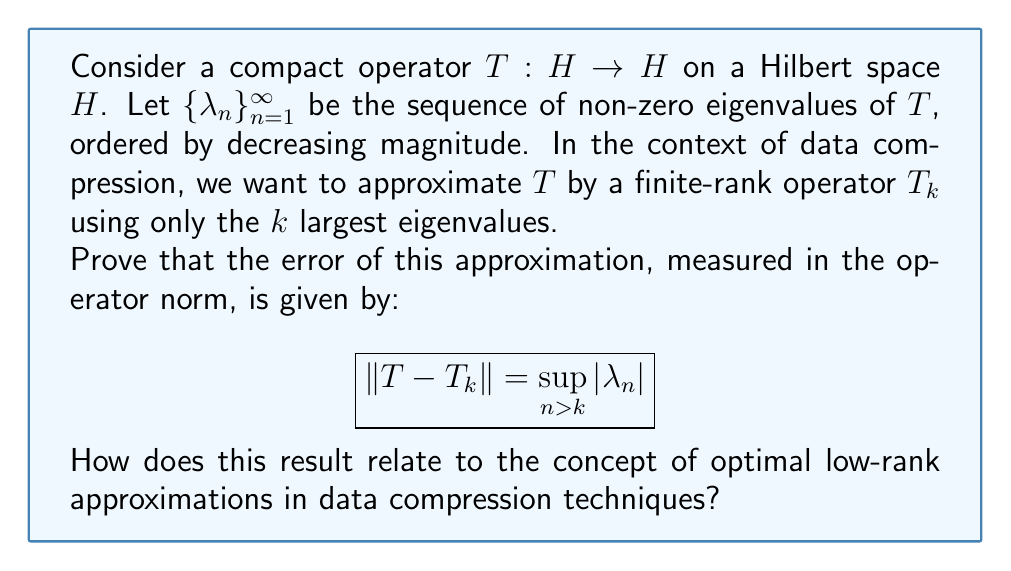Show me your answer to this math problem. Let's approach this proof step-by-step:

1) First, recall that for a compact operator $T$ on a Hilbert space, we have the spectral theorem:

   $$T = \sum_{n=1}^{\infty} \lambda_n \langle \cdot, e_n \rangle f_n$$

   where $\{e_n\}$ and $\{f_n\}$ are orthonormal sequences in $H$.

2) The finite-rank approximation $T_k$ is defined as:

   $$T_k = \sum_{n=1}^{k} \lambda_n \langle \cdot, e_n \rangle f_n$$

3) The difference $T - T_k$ is thus:

   $$T - T_k = \sum_{n=k+1}^{\infty} \lambda_n \langle \cdot, e_n \rangle f_n$$

4) Now, for any $x \in H$ with $\|x\| = 1$:

   $$\|(T - T_k)x\|^2 = \left\|\sum_{n=k+1}^{\infty} \lambda_n \langle x, e_n \rangle f_n\right\|^2 = \sum_{n=k+1}^{\infty} |\lambda_n|^2 |\langle x, e_n \rangle|^2$$

5) Since $\sum_{n=1}^{\infty} |\langle x, e_n \rangle|^2 \leq \|x\|^2 = 1$, we have:

   $$\|(T - T_k)x\|^2 \leq \sup_{n > k} |\lambda_n|^2 \sum_{n=k+1}^{\infty} |\langle x, e_n \rangle|^2 \leq \sup_{n > k} |\lambda_n|^2$$

6) Therefore, $\|T - T_k\| \leq \sup_{n > k} |\lambda_n|$

7) To show equality, consider the sequence $x_m = e_{k+m}$ for $m \geq 1$. We have:

   $$\|(T - T_k)x_m\| = |\lambda_{k+m}|$$

8) Taking the supremum over $m$, we get:

   $$\|T - T_k\| \geq \sup_{n > k} |\lambda_n|$$

9) Combining steps 6 and 8, we conclude:

   $$\|T - T_k\| = \sup_{n > k} |\lambda_n|$$

This result relates to data compression techniques as follows:

- In data compression, we often want to approximate high-dimensional data with lower-dimensional representations.
- This theorem shows that by keeping the $k$ largest eigenvalues, we minimize the error of approximation in the operator norm.
- This is the mathematical foundation for techniques like Principal Component Analysis (PCA) in data compression, where we project data onto the subspace spanned by the eigenvectors corresponding to the largest eigenvalues.
- The error bound given by $\sup_{n > k} |\lambda_n|$ provides a quantitative measure of how much information is lost in the compression process.
Answer: $\|T - T_k\| = \sup_{n > k} |\lambda_n|$ 